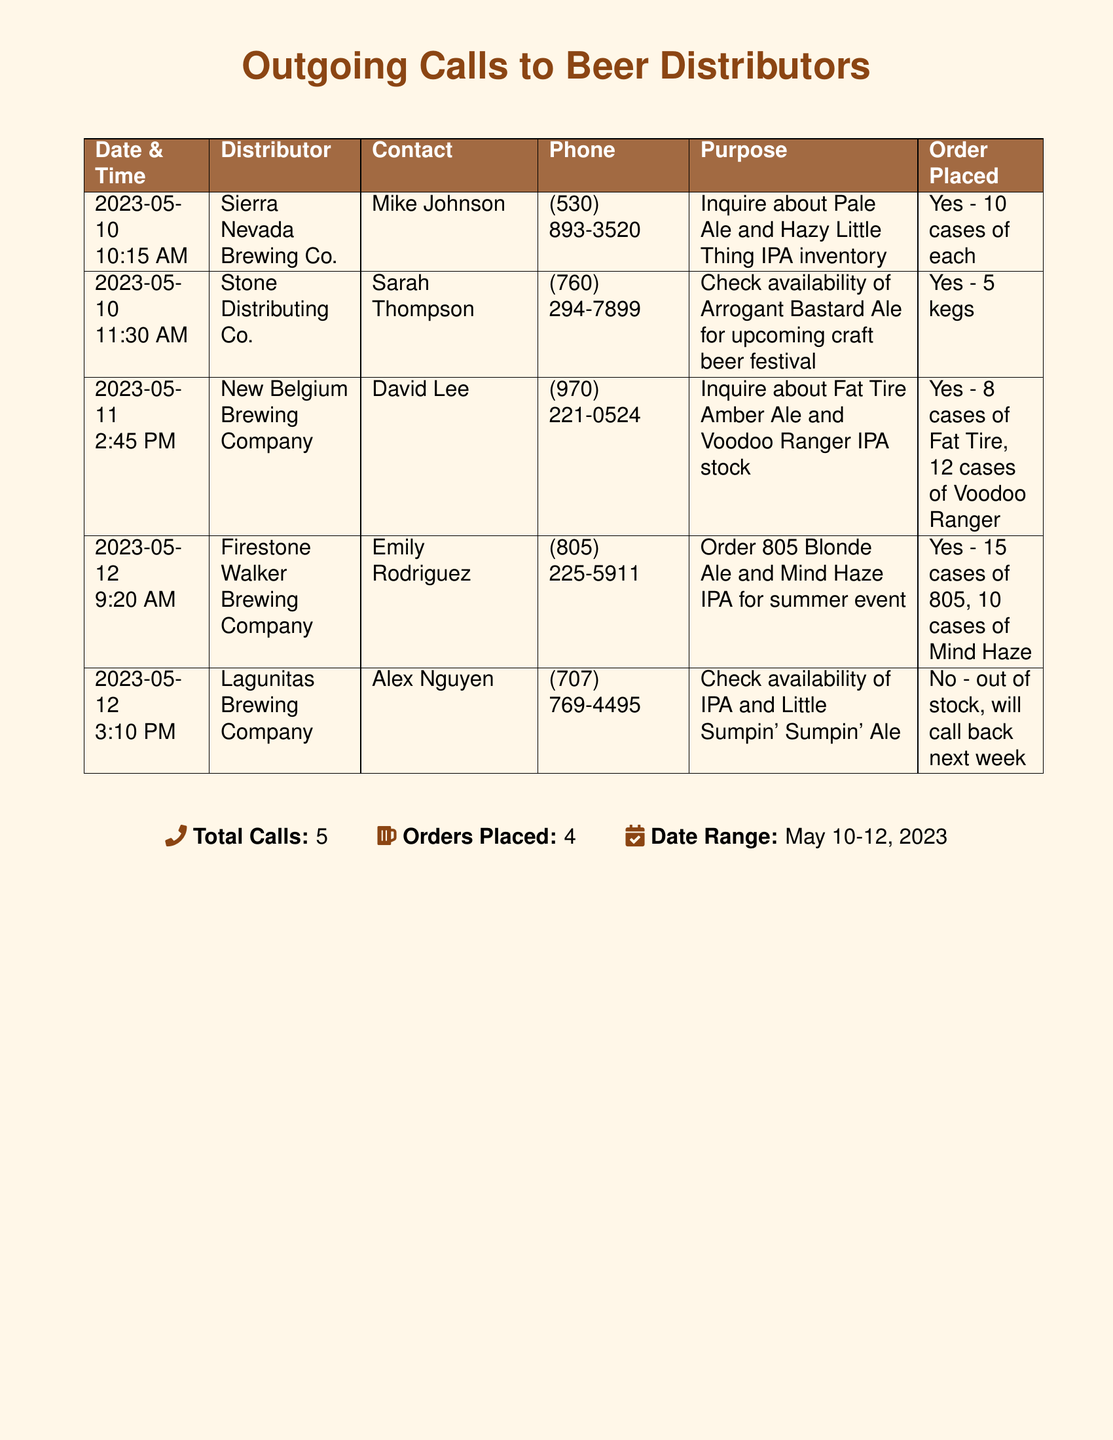What is the total number of calls made? The total number of calls made is mentioned at the bottom of the document as Total Calls.
Answer: 5 Which distributor was called on May 11? The entry for May 11 lists New Belgium Brewing Company as the distributor contacted that day.
Answer: New Belgium Brewing Company How many cases of Fat Tire Amber Ale were ordered? The number of cases ordered for Fat Tire Amber Ale is specified in the order details for New Belgium Brewing Company.
Answer: 8 cases What purpose was listed for the call to Stone Distributing Co.? The purpose of the call to Stone Distributing Co. is given, detailing the inquiry about Arrogant Bastard Ale.
Answer: Check availability of Arrogant Bastard Ale for upcoming craft beer festival Who was the contact person for the call to Firestone Walker Brewing Company? The contact person for Firestone Walker Brewing Company is noted next to their entry in the document.
Answer: Emily Rodriguez What is the date range of the calls made? The date range for the calls is specified at the bottom of the table under Date Range.
Answer: May 10-12, 2023 